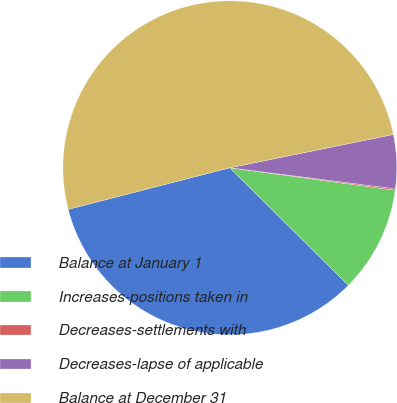Convert chart. <chart><loc_0><loc_0><loc_500><loc_500><pie_chart><fcel>Balance at January 1<fcel>Increases-positions taken in<fcel>Decreases-settlements with<fcel>Decreases-lapse of applicable<fcel>Balance at December 31<nl><fcel>33.56%<fcel>10.28%<fcel>0.14%<fcel>5.21%<fcel>50.82%<nl></chart> 